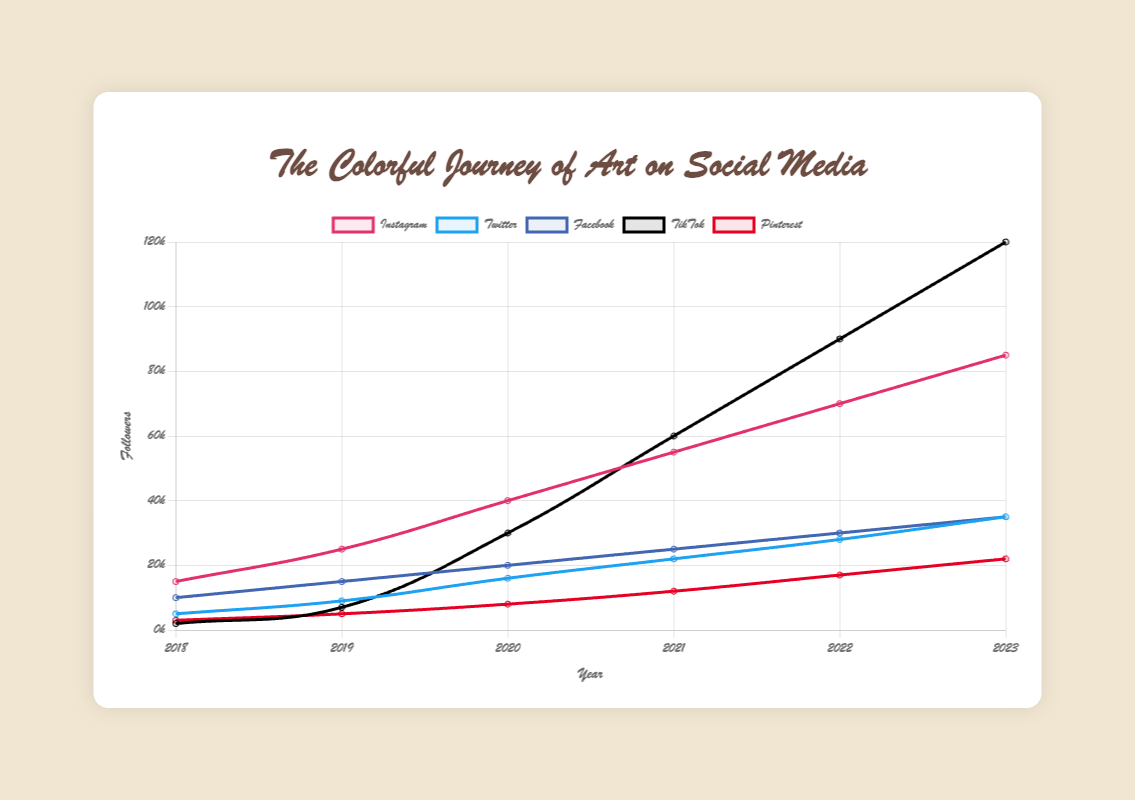What is the difference in followers between TikTok and Instagram in 2023? In 2023, TikTok has 120,000 followers, and Instagram has 85,000 followers. The difference is 120,000 - 85,000 = 35,000 followers.
Answer: 35,000 Which platform had the highest growth in followers between 2019 and 2020? TikTok grew from 7,000 followers in 2019 to 30,000 followers in 2020. The growth is 30,000 - 7,000 = 23,000 followers. No other platform had a higher growth.
Answer: TikTok From 2018 to 2023, how many platforms reached at least 20,000 followers? By 2023, Instagram (85,000), Twitter (35,000), Facebook (35,000), TikTok (120,000), and Pinterest (22,000) all surpassed 20,000 followers. That makes 5 platforms in total.
Answer: 5 Which platform had the smallest increase in followers from 2021 to 2022, and by how much? Pinterest increased from 12,000 followers in 2021 to 17,000 in 2022, an increase of 17,000 - 12,000 = 5,000 followers, which is the smallest among all platforms.
Answer: Pinterest, 5,000 Between which two consecutive years did Instagram see the greatest increase in followers, and what was the number of followers added during that period? From 2019 to 2020, Instagram went from 25,000 to 40,000 followers, a difference of 40,000 - 25,000 = 15,000. This is the largest yearly increase for Instagram.
Answer: 2019 to 2020, 15,000 What is the total number of followers for Twitter across all years presented (2018 to 2023)? Summing the followers from each year for Twitter: 5,000 (2018) + 9,000 (2019) + 16,000 (2020) + 22,000 (2021) + 28,000 (2022) + 35,000 (2023) = 115,000.
Answer: 115,000 What are the respective follower counts for Facebook and Twitter in 2022, and how do they compare to each other? In 2022, Facebook has 30,000 followers, and Twitter has 28,000 followers. Facebook has 2,000 more followers than Twitter.
Answer: Facebook has 30,000, Twitter has 28,000; Facebook has 2,000 more Which platform showed the sharpest incline visually between 2020 and 2021? By observing the slope of the lines, TikTok increased sharply from 30,000 to 60,000 between 2020 and 2021, indicating the steepest visual incline.
Answer: TikTok In what year did Pinterest first surpass 10,000 followers? By checking the values, Pinterest reached 12,000 followers in 2021, which is the first year it surpassed 10,000 followers.
Answer: 2021 